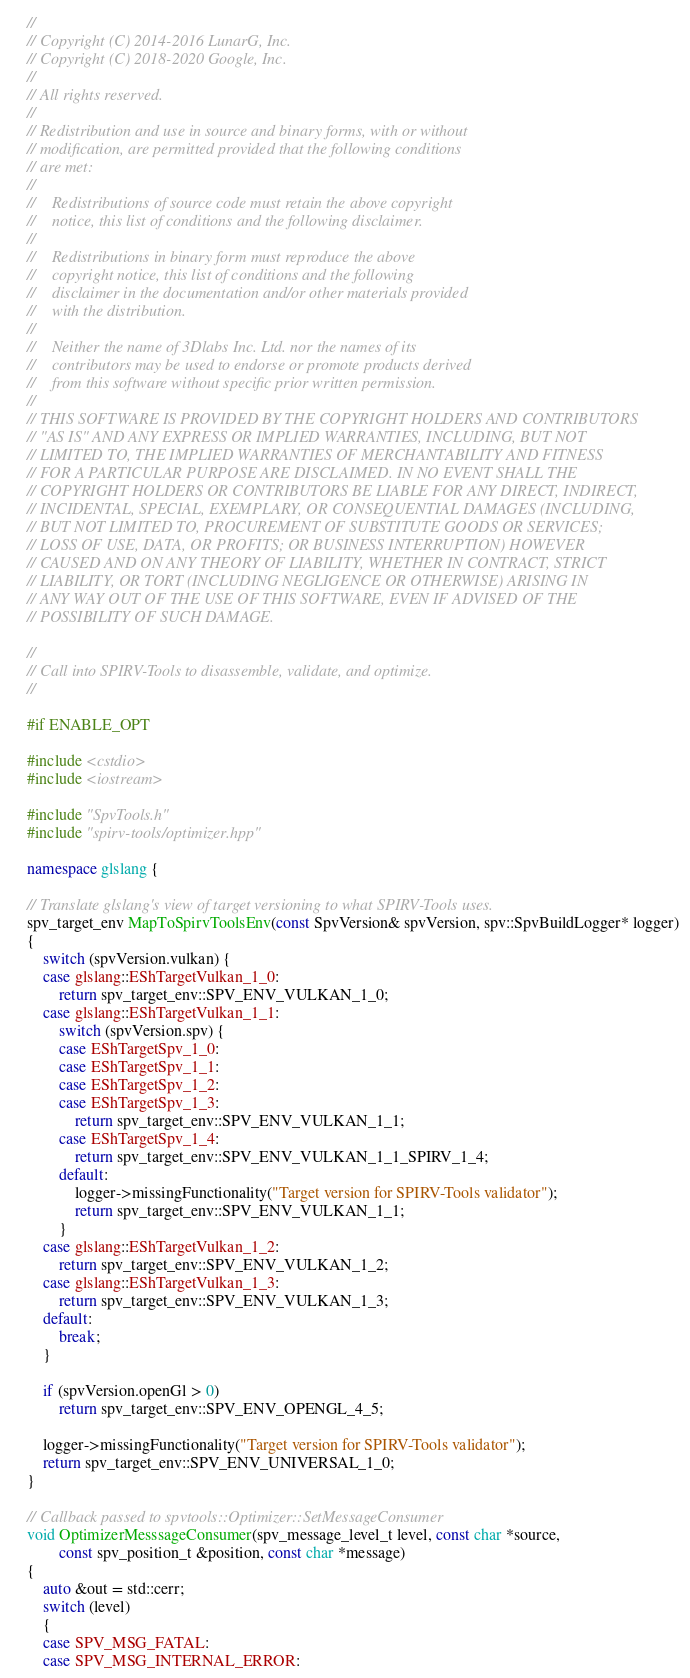Convert code to text. <code><loc_0><loc_0><loc_500><loc_500><_C++_>//
// Copyright (C) 2014-2016 LunarG, Inc.
// Copyright (C) 2018-2020 Google, Inc.
//
// All rights reserved.
//
// Redistribution and use in source and binary forms, with or without
// modification, are permitted provided that the following conditions
// are met:
//
//    Redistributions of source code must retain the above copyright
//    notice, this list of conditions and the following disclaimer.
//
//    Redistributions in binary form must reproduce the above
//    copyright notice, this list of conditions and the following
//    disclaimer in the documentation and/or other materials provided
//    with the distribution.
//
//    Neither the name of 3Dlabs Inc. Ltd. nor the names of its
//    contributors may be used to endorse or promote products derived
//    from this software without specific prior written permission.
//
// THIS SOFTWARE IS PROVIDED BY THE COPYRIGHT HOLDERS AND CONTRIBUTORS
// "AS IS" AND ANY EXPRESS OR IMPLIED WARRANTIES, INCLUDING, BUT NOT
// LIMITED TO, THE IMPLIED WARRANTIES OF MERCHANTABILITY AND FITNESS
// FOR A PARTICULAR PURPOSE ARE DISCLAIMED. IN NO EVENT SHALL THE
// COPYRIGHT HOLDERS OR CONTRIBUTORS BE LIABLE FOR ANY DIRECT, INDIRECT,
// INCIDENTAL, SPECIAL, EXEMPLARY, OR CONSEQUENTIAL DAMAGES (INCLUDING,
// BUT NOT LIMITED TO, PROCUREMENT OF SUBSTITUTE GOODS OR SERVICES;
// LOSS OF USE, DATA, OR PROFITS; OR BUSINESS INTERRUPTION) HOWEVER
// CAUSED AND ON ANY THEORY OF LIABILITY, WHETHER IN CONTRACT, STRICT
// LIABILITY, OR TORT (INCLUDING NEGLIGENCE OR OTHERWISE) ARISING IN
// ANY WAY OUT OF THE USE OF THIS SOFTWARE, EVEN IF ADVISED OF THE
// POSSIBILITY OF SUCH DAMAGE.

//
// Call into SPIRV-Tools to disassemble, validate, and optimize.
//

#if ENABLE_OPT

#include <cstdio>
#include <iostream>

#include "SpvTools.h"
#include "spirv-tools/optimizer.hpp"

namespace glslang {

// Translate glslang's view of target versioning to what SPIRV-Tools uses.
spv_target_env MapToSpirvToolsEnv(const SpvVersion& spvVersion, spv::SpvBuildLogger* logger)
{
    switch (spvVersion.vulkan) {
    case glslang::EShTargetVulkan_1_0:
        return spv_target_env::SPV_ENV_VULKAN_1_0;
    case glslang::EShTargetVulkan_1_1:
        switch (spvVersion.spv) {
        case EShTargetSpv_1_0:
        case EShTargetSpv_1_1:
        case EShTargetSpv_1_2:
        case EShTargetSpv_1_3:
            return spv_target_env::SPV_ENV_VULKAN_1_1;
        case EShTargetSpv_1_4:
            return spv_target_env::SPV_ENV_VULKAN_1_1_SPIRV_1_4;
        default:
            logger->missingFunctionality("Target version for SPIRV-Tools validator");
            return spv_target_env::SPV_ENV_VULKAN_1_1;
        }
    case glslang::EShTargetVulkan_1_2:
        return spv_target_env::SPV_ENV_VULKAN_1_2;
    case glslang::EShTargetVulkan_1_3:
        return spv_target_env::SPV_ENV_VULKAN_1_3;
    default:
        break;
    }

    if (spvVersion.openGl > 0)
        return spv_target_env::SPV_ENV_OPENGL_4_5;

    logger->missingFunctionality("Target version for SPIRV-Tools validator");
    return spv_target_env::SPV_ENV_UNIVERSAL_1_0;
}

// Callback passed to spvtools::Optimizer::SetMessageConsumer
void OptimizerMesssageConsumer(spv_message_level_t level, const char *source,
        const spv_position_t &position, const char *message)
{
    auto &out = std::cerr;
    switch (level)
    {
    case SPV_MSG_FATAL:
    case SPV_MSG_INTERNAL_ERROR:</code> 